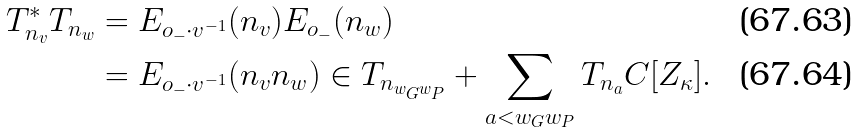<formula> <loc_0><loc_0><loc_500><loc_500>T _ { n _ { v } } ^ { * } T _ { n _ { w } } & = E _ { o _ { - } \cdot v ^ { - 1 } } ( n _ { v } ) E _ { o _ { - } } ( n _ { w } ) \\ & = E _ { o _ { - } \cdot v ^ { - 1 } } ( n _ { v } n _ { w } ) \in T _ { n _ { w _ { G } w _ { P } } } + \sum _ { a < w _ { G } w _ { P } } T _ { n _ { a } } C [ Z _ { \kappa } ] .</formula> 